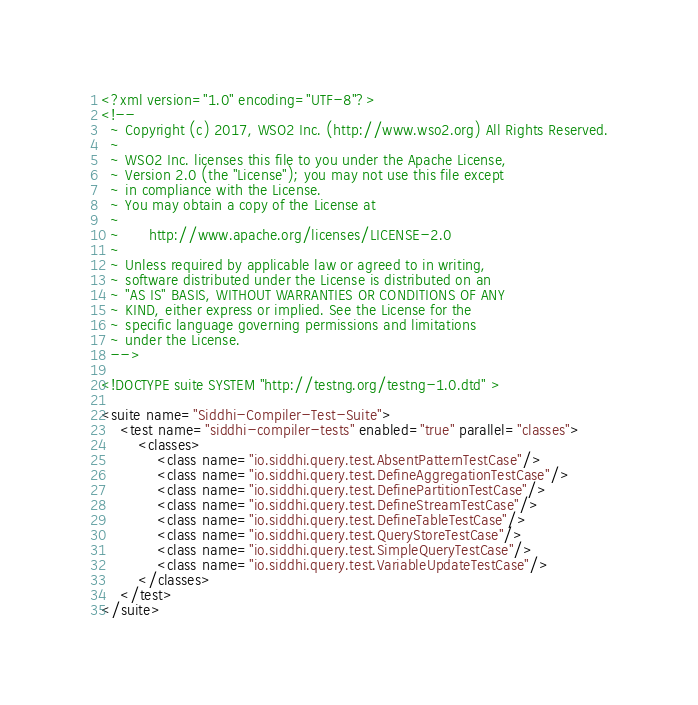Convert code to text. <code><loc_0><loc_0><loc_500><loc_500><_XML_><?xml version="1.0" encoding="UTF-8"?>
<!--
  ~ Copyright (c) 2017, WSO2 Inc. (http://www.wso2.org) All Rights Reserved.
  ~
  ~ WSO2 Inc. licenses this file to you under the Apache License,
  ~ Version 2.0 (the "License"); you may not use this file except
  ~ in compliance with the License.
  ~ You may obtain a copy of the License at
  ~
  ~      http://www.apache.org/licenses/LICENSE-2.0
  ~
  ~ Unless required by applicable law or agreed to in writing,
  ~ software distributed under the License is distributed on an
  ~ "AS IS" BASIS, WITHOUT WARRANTIES OR CONDITIONS OF ANY
  ~ KIND, either express or implied. See the License for the
  ~ specific language governing permissions and limitations
  ~ under the License.
  -->

<!DOCTYPE suite SYSTEM "http://testng.org/testng-1.0.dtd" >

<suite name="Siddhi-Compiler-Test-Suite">
    <test name="siddhi-compiler-tests" enabled="true" parallel="classes">
        <classes>
            <class name="io.siddhi.query.test.AbsentPatternTestCase"/>
            <class name="io.siddhi.query.test.DefineAggregationTestCase"/>
            <class name="io.siddhi.query.test.DefinePartitionTestCase"/>
            <class name="io.siddhi.query.test.DefineStreamTestCase"/>
            <class name="io.siddhi.query.test.DefineTableTestCase"/>
            <class name="io.siddhi.query.test.QueryStoreTestCase"/>
            <class name="io.siddhi.query.test.SimpleQueryTestCase"/>
            <class name="io.siddhi.query.test.VariableUpdateTestCase"/>
        </classes>
    </test>
</suite></code> 